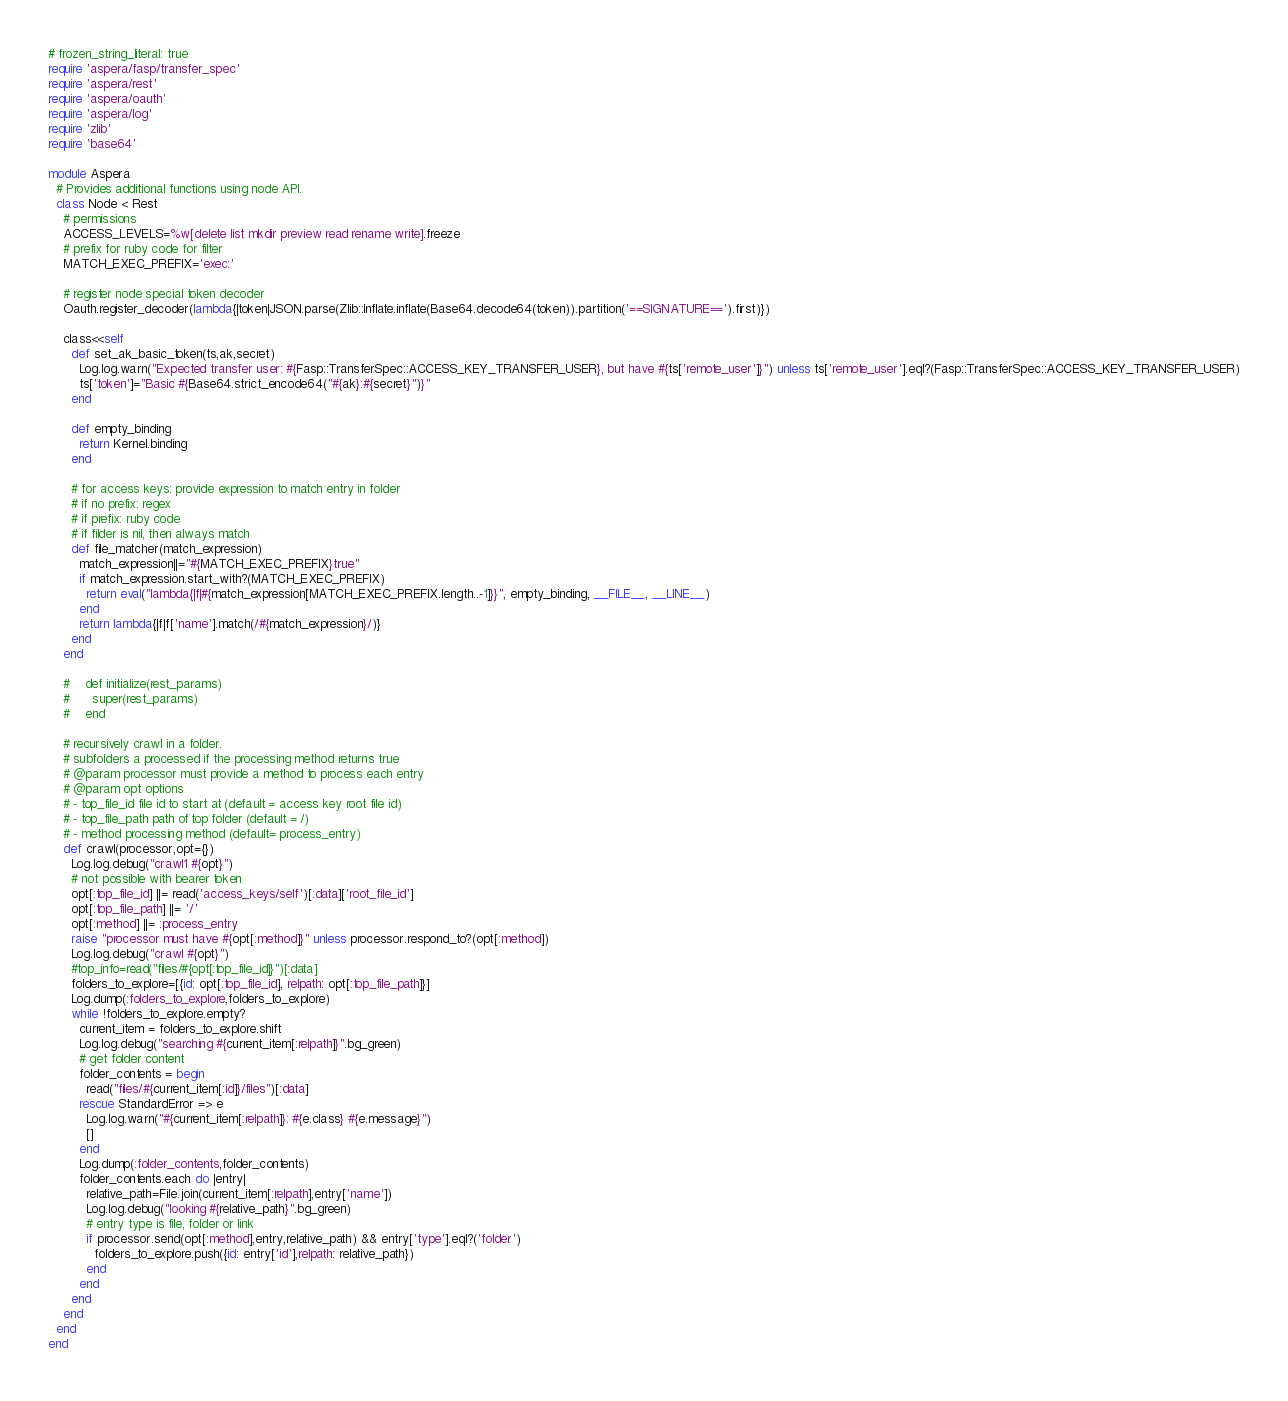Convert code to text. <code><loc_0><loc_0><loc_500><loc_500><_Ruby_># frozen_string_literal: true
require 'aspera/fasp/transfer_spec'
require 'aspera/rest'
require 'aspera/oauth'
require 'aspera/log'
require 'zlib'
require 'base64'

module Aspera
  # Provides additional functions using node API.
  class Node < Rest
    # permissions
    ACCESS_LEVELS=%w[delete list mkdir preview read rename write].freeze
    # prefix for ruby code for filter
    MATCH_EXEC_PREFIX='exec:'

    # register node special token decoder
    Oauth.register_decoder(lambda{|token|JSON.parse(Zlib::Inflate.inflate(Base64.decode64(token)).partition('==SIGNATURE==').first)})

    class<<self
      def set_ak_basic_token(ts,ak,secret)
        Log.log.warn("Expected transfer user: #{Fasp::TransferSpec::ACCESS_KEY_TRANSFER_USER}, but have #{ts['remote_user']}") unless ts['remote_user'].eql?(Fasp::TransferSpec::ACCESS_KEY_TRANSFER_USER)
        ts['token']="Basic #{Base64.strict_encode64("#{ak}:#{secret}")}"
      end

      def empty_binding
        return Kernel.binding
      end

      # for access keys: provide expression to match entry in folder
      # if no prefix: regex
      # if prefix: ruby code
      # if filder is nil, then always match
      def file_matcher(match_expression)
        match_expression||="#{MATCH_EXEC_PREFIX}true"
        if match_expression.start_with?(MATCH_EXEC_PREFIX)
          return eval("lambda{|f|#{match_expression[MATCH_EXEC_PREFIX.length..-1]}}", empty_binding, __FILE__, __LINE__)
        end
        return lambda{|f|f['name'].match(/#{match_expression}/)}
      end
    end

    #    def initialize(rest_params)
    #      super(rest_params)
    #    end

    # recursively crawl in a folder.
    # subfolders a processed if the processing method returns true
    # @param processor must provide a method to process each entry
    # @param opt options
    # - top_file_id file id to start at (default = access key root file id)
    # - top_file_path path of top folder (default = /)
    # - method processing method (default= process_entry)
    def crawl(processor,opt={})
      Log.log.debug("crawl1 #{opt}")
      # not possible with bearer token
      opt[:top_file_id] ||= read('access_keys/self')[:data]['root_file_id']
      opt[:top_file_path] ||= '/'
      opt[:method] ||= :process_entry
      raise "processor must have #{opt[:method]}" unless processor.respond_to?(opt[:method])
      Log.log.debug("crawl #{opt}")
      #top_info=read("files/#{opt[:top_file_id]}")[:data]
      folders_to_explore=[{id: opt[:top_file_id], relpath: opt[:top_file_path]}]
      Log.dump(:folders_to_explore,folders_to_explore)
      while !folders_to_explore.empty?
        current_item = folders_to_explore.shift
        Log.log.debug("searching #{current_item[:relpath]}".bg_green)
        # get folder content
        folder_contents = begin
          read("files/#{current_item[:id]}/files")[:data]
        rescue StandardError => e
          Log.log.warn("#{current_item[:relpath]}: #{e.class} #{e.message}")
          []
        end
        Log.dump(:folder_contents,folder_contents)
        folder_contents.each do |entry|
          relative_path=File.join(current_item[:relpath],entry['name'])
          Log.log.debug("looking #{relative_path}".bg_green)
          # entry type is file, folder or link
          if processor.send(opt[:method],entry,relative_path) && entry['type'].eql?('folder')
            folders_to_explore.push({id: entry['id'],relpath: relative_path})
          end
        end
      end
    end
  end
end
</code> 